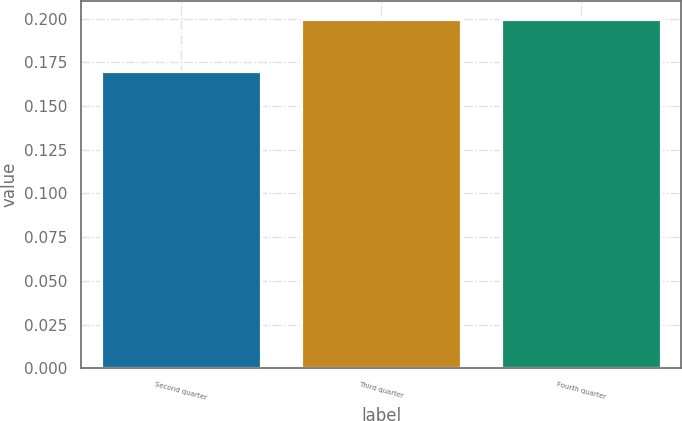<chart> <loc_0><loc_0><loc_500><loc_500><bar_chart><fcel>Second quarter<fcel>Third quarter<fcel>Fourth quarter<nl><fcel>0.17<fcel>0.2<fcel>0.2<nl></chart> 